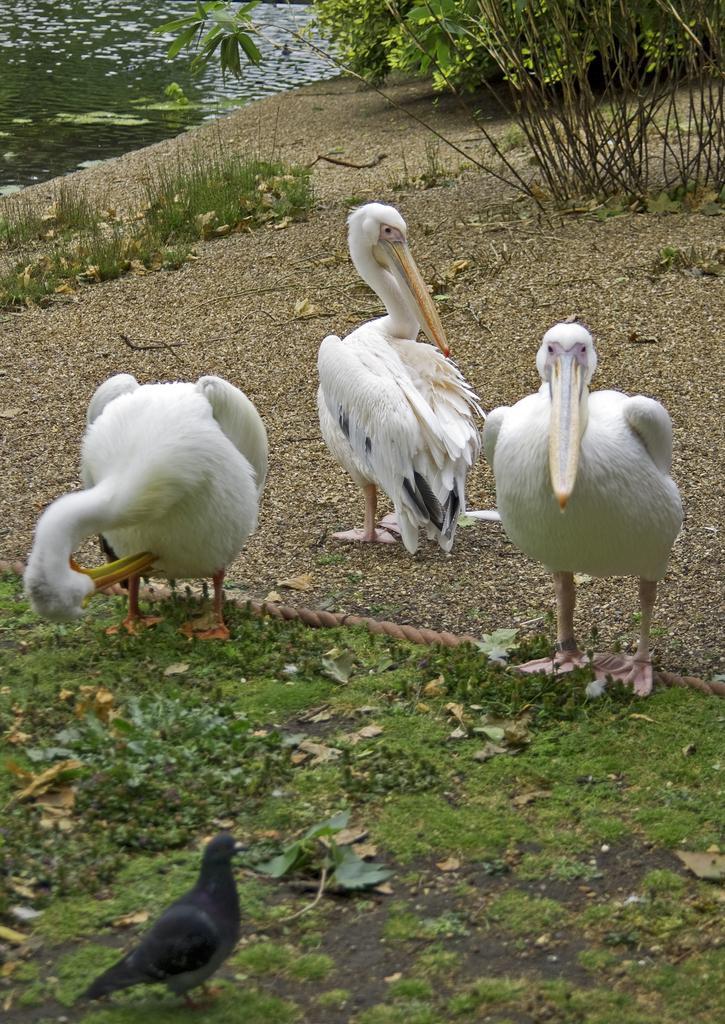How would you summarize this image in a sentence or two? In this image we can see some birds on the ground. We can also see some grass, plants, a rope and the water. 